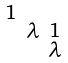<formula> <loc_0><loc_0><loc_500><loc_500>\begin{smallmatrix} 1 & & \\ & \lambda & 1 \\ & & \lambda \end{smallmatrix}</formula> 